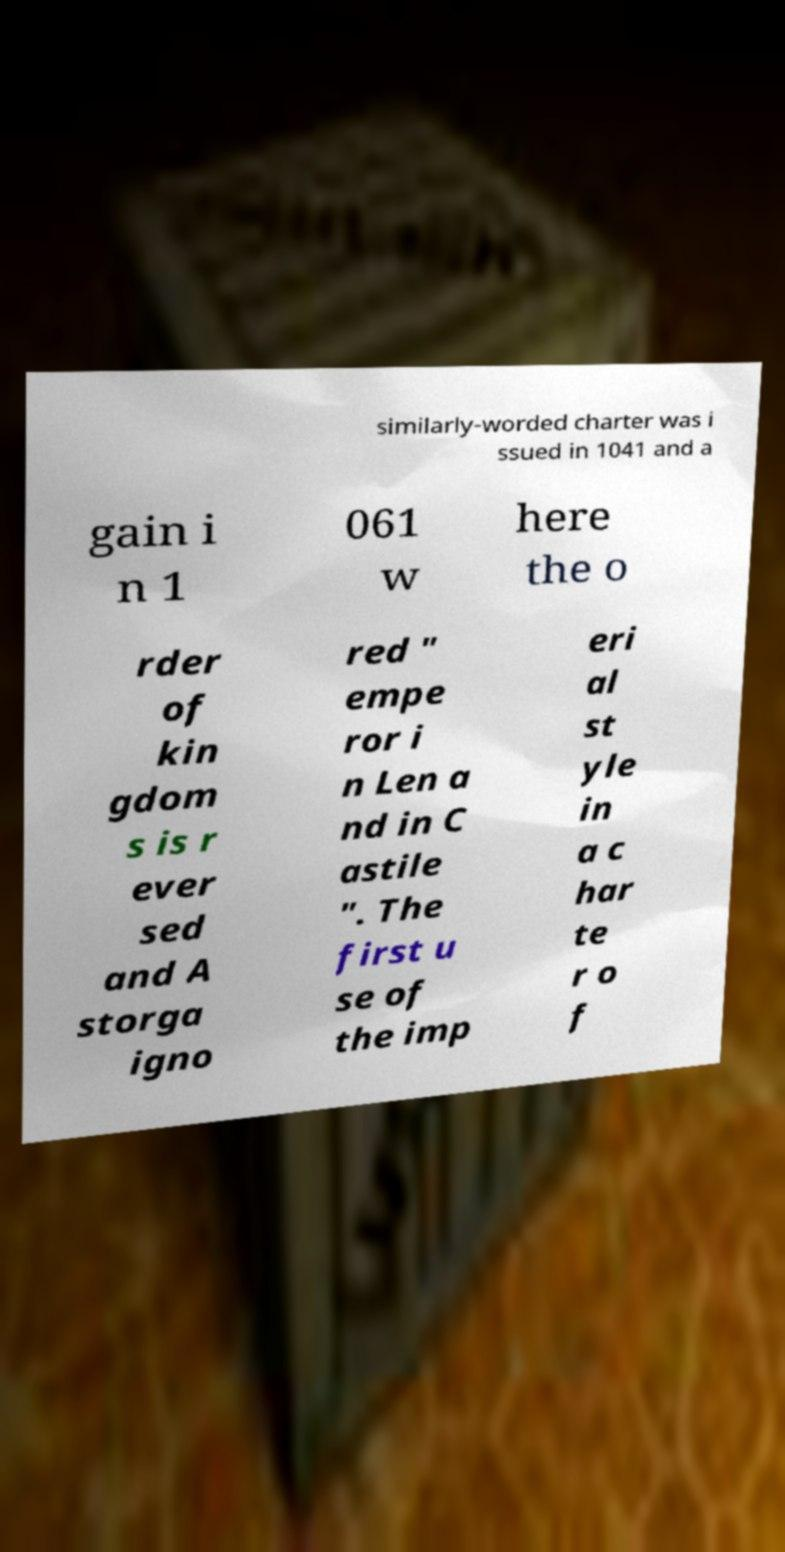What messages or text are displayed in this image? I need them in a readable, typed format. similarly-worded charter was i ssued in 1041 and a gain i n 1 061 w here the o rder of kin gdom s is r ever sed and A storga igno red " empe ror i n Len a nd in C astile ". The first u se of the imp eri al st yle in a c har te r o f 